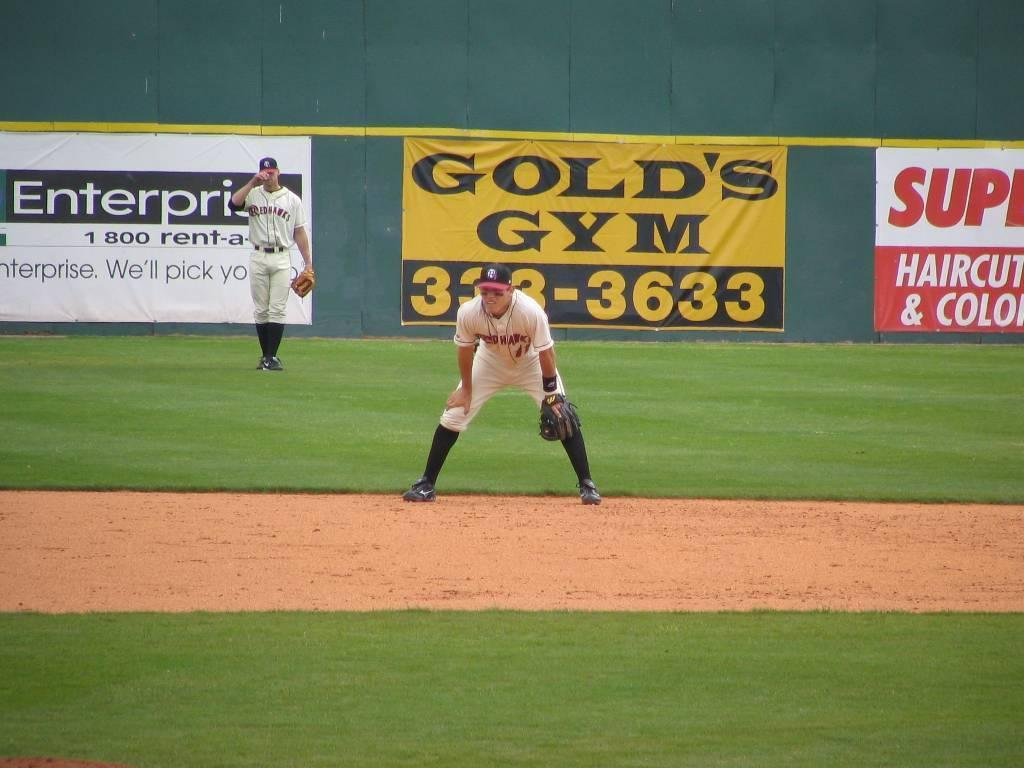<image>
Describe the image concisely. A baseball player waits for a ball to come his way with an Enterprise and Gold's Gym advertisement in the background. 